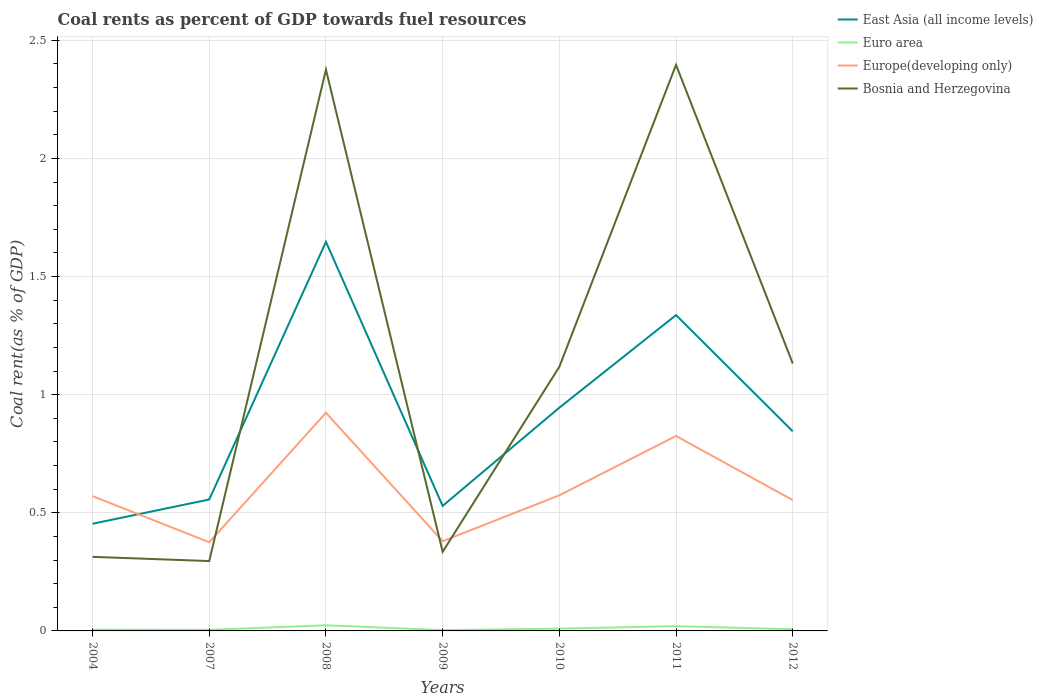Does the line corresponding to Bosnia and Herzegovina intersect with the line corresponding to Euro area?
Your answer should be very brief. No. Is the number of lines equal to the number of legend labels?
Keep it short and to the point. Yes. Across all years, what is the maximum coal rent in East Asia (all income levels)?
Offer a terse response. 0.45. What is the total coal rent in Europe(developing only) in the graph?
Your answer should be compact. -0.25. What is the difference between the highest and the second highest coal rent in Bosnia and Herzegovina?
Offer a terse response. 2.1. How many lines are there?
Offer a very short reply. 4. How many years are there in the graph?
Offer a terse response. 7. Does the graph contain any zero values?
Your response must be concise. No. How many legend labels are there?
Your response must be concise. 4. What is the title of the graph?
Your answer should be very brief. Coal rents as percent of GDP towards fuel resources. Does "Uganda" appear as one of the legend labels in the graph?
Keep it short and to the point. No. What is the label or title of the X-axis?
Make the answer very short. Years. What is the label or title of the Y-axis?
Provide a short and direct response. Coal rent(as % of GDP). What is the Coal rent(as % of GDP) in East Asia (all income levels) in 2004?
Offer a very short reply. 0.45. What is the Coal rent(as % of GDP) in Euro area in 2004?
Make the answer very short. 0.01. What is the Coal rent(as % of GDP) in Europe(developing only) in 2004?
Provide a succinct answer. 0.57. What is the Coal rent(as % of GDP) of Bosnia and Herzegovina in 2004?
Ensure brevity in your answer.  0.31. What is the Coal rent(as % of GDP) of East Asia (all income levels) in 2007?
Your answer should be compact. 0.56. What is the Coal rent(as % of GDP) in Euro area in 2007?
Make the answer very short. 0. What is the Coal rent(as % of GDP) in Europe(developing only) in 2007?
Offer a terse response. 0.38. What is the Coal rent(as % of GDP) of Bosnia and Herzegovina in 2007?
Give a very brief answer. 0.3. What is the Coal rent(as % of GDP) of East Asia (all income levels) in 2008?
Offer a terse response. 1.65. What is the Coal rent(as % of GDP) in Euro area in 2008?
Make the answer very short. 0.02. What is the Coal rent(as % of GDP) of Europe(developing only) in 2008?
Your answer should be compact. 0.92. What is the Coal rent(as % of GDP) in Bosnia and Herzegovina in 2008?
Offer a very short reply. 2.38. What is the Coal rent(as % of GDP) in East Asia (all income levels) in 2009?
Make the answer very short. 0.53. What is the Coal rent(as % of GDP) in Euro area in 2009?
Provide a short and direct response. 0. What is the Coal rent(as % of GDP) of Europe(developing only) in 2009?
Make the answer very short. 0.38. What is the Coal rent(as % of GDP) in Bosnia and Herzegovina in 2009?
Your answer should be very brief. 0.33. What is the Coal rent(as % of GDP) in East Asia (all income levels) in 2010?
Give a very brief answer. 0.95. What is the Coal rent(as % of GDP) of Euro area in 2010?
Ensure brevity in your answer.  0.01. What is the Coal rent(as % of GDP) in Europe(developing only) in 2010?
Your response must be concise. 0.57. What is the Coal rent(as % of GDP) of Bosnia and Herzegovina in 2010?
Make the answer very short. 1.12. What is the Coal rent(as % of GDP) of East Asia (all income levels) in 2011?
Provide a short and direct response. 1.34. What is the Coal rent(as % of GDP) of Euro area in 2011?
Offer a terse response. 0.02. What is the Coal rent(as % of GDP) of Europe(developing only) in 2011?
Give a very brief answer. 0.83. What is the Coal rent(as % of GDP) of Bosnia and Herzegovina in 2011?
Offer a terse response. 2.4. What is the Coal rent(as % of GDP) of East Asia (all income levels) in 2012?
Give a very brief answer. 0.84. What is the Coal rent(as % of GDP) of Euro area in 2012?
Your response must be concise. 0.01. What is the Coal rent(as % of GDP) of Europe(developing only) in 2012?
Your answer should be very brief. 0.55. What is the Coal rent(as % of GDP) of Bosnia and Herzegovina in 2012?
Give a very brief answer. 1.13. Across all years, what is the maximum Coal rent(as % of GDP) in East Asia (all income levels)?
Provide a short and direct response. 1.65. Across all years, what is the maximum Coal rent(as % of GDP) in Euro area?
Offer a very short reply. 0.02. Across all years, what is the maximum Coal rent(as % of GDP) of Europe(developing only)?
Make the answer very short. 0.92. Across all years, what is the maximum Coal rent(as % of GDP) of Bosnia and Herzegovina?
Your response must be concise. 2.4. Across all years, what is the minimum Coal rent(as % of GDP) in East Asia (all income levels)?
Offer a terse response. 0.45. Across all years, what is the minimum Coal rent(as % of GDP) of Euro area?
Ensure brevity in your answer.  0. Across all years, what is the minimum Coal rent(as % of GDP) in Europe(developing only)?
Offer a terse response. 0.38. Across all years, what is the minimum Coal rent(as % of GDP) in Bosnia and Herzegovina?
Offer a terse response. 0.3. What is the total Coal rent(as % of GDP) of East Asia (all income levels) in the graph?
Provide a succinct answer. 6.31. What is the total Coal rent(as % of GDP) of Euro area in the graph?
Offer a very short reply. 0.07. What is the total Coal rent(as % of GDP) in Europe(developing only) in the graph?
Keep it short and to the point. 4.2. What is the total Coal rent(as % of GDP) of Bosnia and Herzegovina in the graph?
Give a very brief answer. 7.97. What is the difference between the Coal rent(as % of GDP) of East Asia (all income levels) in 2004 and that in 2007?
Provide a succinct answer. -0.1. What is the difference between the Coal rent(as % of GDP) of Euro area in 2004 and that in 2007?
Provide a short and direct response. 0. What is the difference between the Coal rent(as % of GDP) in Europe(developing only) in 2004 and that in 2007?
Your answer should be very brief. 0.2. What is the difference between the Coal rent(as % of GDP) of Bosnia and Herzegovina in 2004 and that in 2007?
Give a very brief answer. 0.02. What is the difference between the Coal rent(as % of GDP) of East Asia (all income levels) in 2004 and that in 2008?
Make the answer very short. -1.19. What is the difference between the Coal rent(as % of GDP) in Euro area in 2004 and that in 2008?
Offer a terse response. -0.02. What is the difference between the Coal rent(as % of GDP) in Europe(developing only) in 2004 and that in 2008?
Make the answer very short. -0.35. What is the difference between the Coal rent(as % of GDP) in Bosnia and Herzegovina in 2004 and that in 2008?
Ensure brevity in your answer.  -2.06. What is the difference between the Coal rent(as % of GDP) of East Asia (all income levels) in 2004 and that in 2009?
Ensure brevity in your answer.  -0.08. What is the difference between the Coal rent(as % of GDP) in Euro area in 2004 and that in 2009?
Provide a succinct answer. 0. What is the difference between the Coal rent(as % of GDP) in Europe(developing only) in 2004 and that in 2009?
Your answer should be compact. 0.19. What is the difference between the Coal rent(as % of GDP) in Bosnia and Herzegovina in 2004 and that in 2009?
Keep it short and to the point. -0.02. What is the difference between the Coal rent(as % of GDP) in East Asia (all income levels) in 2004 and that in 2010?
Provide a succinct answer. -0.49. What is the difference between the Coal rent(as % of GDP) of Euro area in 2004 and that in 2010?
Make the answer very short. -0. What is the difference between the Coal rent(as % of GDP) in Europe(developing only) in 2004 and that in 2010?
Keep it short and to the point. -0. What is the difference between the Coal rent(as % of GDP) of Bosnia and Herzegovina in 2004 and that in 2010?
Your answer should be compact. -0.8. What is the difference between the Coal rent(as % of GDP) of East Asia (all income levels) in 2004 and that in 2011?
Ensure brevity in your answer.  -0.88. What is the difference between the Coal rent(as % of GDP) of Euro area in 2004 and that in 2011?
Provide a short and direct response. -0.01. What is the difference between the Coal rent(as % of GDP) in Europe(developing only) in 2004 and that in 2011?
Ensure brevity in your answer.  -0.25. What is the difference between the Coal rent(as % of GDP) of Bosnia and Herzegovina in 2004 and that in 2011?
Give a very brief answer. -2.08. What is the difference between the Coal rent(as % of GDP) of East Asia (all income levels) in 2004 and that in 2012?
Your response must be concise. -0.39. What is the difference between the Coal rent(as % of GDP) in Euro area in 2004 and that in 2012?
Provide a succinct answer. -0. What is the difference between the Coal rent(as % of GDP) in Europe(developing only) in 2004 and that in 2012?
Give a very brief answer. 0.02. What is the difference between the Coal rent(as % of GDP) in Bosnia and Herzegovina in 2004 and that in 2012?
Keep it short and to the point. -0.82. What is the difference between the Coal rent(as % of GDP) in East Asia (all income levels) in 2007 and that in 2008?
Keep it short and to the point. -1.09. What is the difference between the Coal rent(as % of GDP) in Euro area in 2007 and that in 2008?
Offer a terse response. -0.02. What is the difference between the Coal rent(as % of GDP) of Europe(developing only) in 2007 and that in 2008?
Make the answer very short. -0.55. What is the difference between the Coal rent(as % of GDP) in Bosnia and Herzegovina in 2007 and that in 2008?
Your answer should be compact. -2.08. What is the difference between the Coal rent(as % of GDP) of East Asia (all income levels) in 2007 and that in 2009?
Make the answer very short. 0.03. What is the difference between the Coal rent(as % of GDP) in Euro area in 2007 and that in 2009?
Your answer should be very brief. 0. What is the difference between the Coal rent(as % of GDP) in Europe(developing only) in 2007 and that in 2009?
Ensure brevity in your answer.  -0. What is the difference between the Coal rent(as % of GDP) in Bosnia and Herzegovina in 2007 and that in 2009?
Offer a terse response. -0.04. What is the difference between the Coal rent(as % of GDP) of East Asia (all income levels) in 2007 and that in 2010?
Offer a terse response. -0.39. What is the difference between the Coal rent(as % of GDP) in Euro area in 2007 and that in 2010?
Make the answer very short. -0.01. What is the difference between the Coal rent(as % of GDP) of Europe(developing only) in 2007 and that in 2010?
Your answer should be compact. -0.2. What is the difference between the Coal rent(as % of GDP) in Bosnia and Herzegovina in 2007 and that in 2010?
Your answer should be very brief. -0.82. What is the difference between the Coal rent(as % of GDP) of East Asia (all income levels) in 2007 and that in 2011?
Provide a short and direct response. -0.78. What is the difference between the Coal rent(as % of GDP) in Euro area in 2007 and that in 2011?
Your answer should be very brief. -0.02. What is the difference between the Coal rent(as % of GDP) of Europe(developing only) in 2007 and that in 2011?
Ensure brevity in your answer.  -0.45. What is the difference between the Coal rent(as % of GDP) of Bosnia and Herzegovina in 2007 and that in 2011?
Your answer should be compact. -2.1. What is the difference between the Coal rent(as % of GDP) in East Asia (all income levels) in 2007 and that in 2012?
Provide a short and direct response. -0.29. What is the difference between the Coal rent(as % of GDP) in Euro area in 2007 and that in 2012?
Your response must be concise. -0. What is the difference between the Coal rent(as % of GDP) in Europe(developing only) in 2007 and that in 2012?
Ensure brevity in your answer.  -0.18. What is the difference between the Coal rent(as % of GDP) of Bosnia and Herzegovina in 2007 and that in 2012?
Provide a short and direct response. -0.84. What is the difference between the Coal rent(as % of GDP) of East Asia (all income levels) in 2008 and that in 2009?
Your response must be concise. 1.12. What is the difference between the Coal rent(as % of GDP) of Euro area in 2008 and that in 2009?
Give a very brief answer. 0.02. What is the difference between the Coal rent(as % of GDP) of Europe(developing only) in 2008 and that in 2009?
Give a very brief answer. 0.54. What is the difference between the Coal rent(as % of GDP) of Bosnia and Herzegovina in 2008 and that in 2009?
Your answer should be very brief. 2.04. What is the difference between the Coal rent(as % of GDP) in East Asia (all income levels) in 2008 and that in 2010?
Offer a terse response. 0.7. What is the difference between the Coal rent(as % of GDP) in Euro area in 2008 and that in 2010?
Offer a very short reply. 0.01. What is the difference between the Coal rent(as % of GDP) in Europe(developing only) in 2008 and that in 2010?
Give a very brief answer. 0.35. What is the difference between the Coal rent(as % of GDP) in Bosnia and Herzegovina in 2008 and that in 2010?
Ensure brevity in your answer.  1.26. What is the difference between the Coal rent(as % of GDP) in East Asia (all income levels) in 2008 and that in 2011?
Keep it short and to the point. 0.31. What is the difference between the Coal rent(as % of GDP) in Euro area in 2008 and that in 2011?
Give a very brief answer. 0. What is the difference between the Coal rent(as % of GDP) of Europe(developing only) in 2008 and that in 2011?
Provide a succinct answer. 0.1. What is the difference between the Coal rent(as % of GDP) in Bosnia and Herzegovina in 2008 and that in 2011?
Your answer should be very brief. -0.02. What is the difference between the Coal rent(as % of GDP) of East Asia (all income levels) in 2008 and that in 2012?
Your answer should be compact. 0.8. What is the difference between the Coal rent(as % of GDP) of Euro area in 2008 and that in 2012?
Provide a succinct answer. 0.02. What is the difference between the Coal rent(as % of GDP) of Europe(developing only) in 2008 and that in 2012?
Offer a very short reply. 0.37. What is the difference between the Coal rent(as % of GDP) in Bosnia and Herzegovina in 2008 and that in 2012?
Ensure brevity in your answer.  1.24. What is the difference between the Coal rent(as % of GDP) in East Asia (all income levels) in 2009 and that in 2010?
Your answer should be compact. -0.42. What is the difference between the Coal rent(as % of GDP) of Euro area in 2009 and that in 2010?
Ensure brevity in your answer.  -0.01. What is the difference between the Coal rent(as % of GDP) in Europe(developing only) in 2009 and that in 2010?
Keep it short and to the point. -0.19. What is the difference between the Coal rent(as % of GDP) of Bosnia and Herzegovina in 2009 and that in 2010?
Keep it short and to the point. -0.78. What is the difference between the Coal rent(as % of GDP) in East Asia (all income levels) in 2009 and that in 2011?
Give a very brief answer. -0.81. What is the difference between the Coal rent(as % of GDP) in Euro area in 2009 and that in 2011?
Your response must be concise. -0.02. What is the difference between the Coal rent(as % of GDP) in Europe(developing only) in 2009 and that in 2011?
Keep it short and to the point. -0.45. What is the difference between the Coal rent(as % of GDP) of Bosnia and Herzegovina in 2009 and that in 2011?
Ensure brevity in your answer.  -2.06. What is the difference between the Coal rent(as % of GDP) in East Asia (all income levels) in 2009 and that in 2012?
Offer a very short reply. -0.32. What is the difference between the Coal rent(as % of GDP) of Euro area in 2009 and that in 2012?
Give a very brief answer. -0. What is the difference between the Coal rent(as % of GDP) in Europe(developing only) in 2009 and that in 2012?
Provide a succinct answer. -0.17. What is the difference between the Coal rent(as % of GDP) of Bosnia and Herzegovina in 2009 and that in 2012?
Provide a short and direct response. -0.8. What is the difference between the Coal rent(as % of GDP) in East Asia (all income levels) in 2010 and that in 2011?
Offer a very short reply. -0.39. What is the difference between the Coal rent(as % of GDP) of Euro area in 2010 and that in 2011?
Your answer should be very brief. -0.01. What is the difference between the Coal rent(as % of GDP) in Europe(developing only) in 2010 and that in 2011?
Your response must be concise. -0.25. What is the difference between the Coal rent(as % of GDP) of Bosnia and Herzegovina in 2010 and that in 2011?
Ensure brevity in your answer.  -1.28. What is the difference between the Coal rent(as % of GDP) in East Asia (all income levels) in 2010 and that in 2012?
Keep it short and to the point. 0.1. What is the difference between the Coal rent(as % of GDP) of Euro area in 2010 and that in 2012?
Ensure brevity in your answer.  0. What is the difference between the Coal rent(as % of GDP) in Europe(developing only) in 2010 and that in 2012?
Offer a terse response. 0.02. What is the difference between the Coal rent(as % of GDP) of Bosnia and Herzegovina in 2010 and that in 2012?
Give a very brief answer. -0.01. What is the difference between the Coal rent(as % of GDP) of East Asia (all income levels) in 2011 and that in 2012?
Ensure brevity in your answer.  0.49. What is the difference between the Coal rent(as % of GDP) of Euro area in 2011 and that in 2012?
Make the answer very short. 0.01. What is the difference between the Coal rent(as % of GDP) of Europe(developing only) in 2011 and that in 2012?
Offer a very short reply. 0.27. What is the difference between the Coal rent(as % of GDP) in Bosnia and Herzegovina in 2011 and that in 2012?
Offer a very short reply. 1.26. What is the difference between the Coal rent(as % of GDP) in East Asia (all income levels) in 2004 and the Coal rent(as % of GDP) in Euro area in 2007?
Offer a terse response. 0.45. What is the difference between the Coal rent(as % of GDP) in East Asia (all income levels) in 2004 and the Coal rent(as % of GDP) in Europe(developing only) in 2007?
Your answer should be compact. 0.08. What is the difference between the Coal rent(as % of GDP) in East Asia (all income levels) in 2004 and the Coal rent(as % of GDP) in Bosnia and Herzegovina in 2007?
Your answer should be very brief. 0.16. What is the difference between the Coal rent(as % of GDP) of Euro area in 2004 and the Coal rent(as % of GDP) of Europe(developing only) in 2007?
Keep it short and to the point. -0.37. What is the difference between the Coal rent(as % of GDP) of Euro area in 2004 and the Coal rent(as % of GDP) of Bosnia and Herzegovina in 2007?
Your answer should be very brief. -0.29. What is the difference between the Coal rent(as % of GDP) of Europe(developing only) in 2004 and the Coal rent(as % of GDP) of Bosnia and Herzegovina in 2007?
Give a very brief answer. 0.27. What is the difference between the Coal rent(as % of GDP) of East Asia (all income levels) in 2004 and the Coal rent(as % of GDP) of Euro area in 2008?
Ensure brevity in your answer.  0.43. What is the difference between the Coal rent(as % of GDP) in East Asia (all income levels) in 2004 and the Coal rent(as % of GDP) in Europe(developing only) in 2008?
Offer a very short reply. -0.47. What is the difference between the Coal rent(as % of GDP) in East Asia (all income levels) in 2004 and the Coal rent(as % of GDP) in Bosnia and Herzegovina in 2008?
Offer a terse response. -1.92. What is the difference between the Coal rent(as % of GDP) of Euro area in 2004 and the Coal rent(as % of GDP) of Europe(developing only) in 2008?
Ensure brevity in your answer.  -0.92. What is the difference between the Coal rent(as % of GDP) of Euro area in 2004 and the Coal rent(as % of GDP) of Bosnia and Herzegovina in 2008?
Your response must be concise. -2.37. What is the difference between the Coal rent(as % of GDP) in Europe(developing only) in 2004 and the Coal rent(as % of GDP) in Bosnia and Herzegovina in 2008?
Provide a succinct answer. -1.81. What is the difference between the Coal rent(as % of GDP) in East Asia (all income levels) in 2004 and the Coal rent(as % of GDP) in Euro area in 2009?
Give a very brief answer. 0.45. What is the difference between the Coal rent(as % of GDP) in East Asia (all income levels) in 2004 and the Coal rent(as % of GDP) in Europe(developing only) in 2009?
Ensure brevity in your answer.  0.07. What is the difference between the Coal rent(as % of GDP) in East Asia (all income levels) in 2004 and the Coal rent(as % of GDP) in Bosnia and Herzegovina in 2009?
Your answer should be very brief. 0.12. What is the difference between the Coal rent(as % of GDP) in Euro area in 2004 and the Coal rent(as % of GDP) in Europe(developing only) in 2009?
Your answer should be compact. -0.37. What is the difference between the Coal rent(as % of GDP) in Euro area in 2004 and the Coal rent(as % of GDP) in Bosnia and Herzegovina in 2009?
Keep it short and to the point. -0.33. What is the difference between the Coal rent(as % of GDP) in Europe(developing only) in 2004 and the Coal rent(as % of GDP) in Bosnia and Herzegovina in 2009?
Your answer should be compact. 0.24. What is the difference between the Coal rent(as % of GDP) in East Asia (all income levels) in 2004 and the Coal rent(as % of GDP) in Euro area in 2010?
Your answer should be very brief. 0.44. What is the difference between the Coal rent(as % of GDP) of East Asia (all income levels) in 2004 and the Coal rent(as % of GDP) of Europe(developing only) in 2010?
Your answer should be very brief. -0.12. What is the difference between the Coal rent(as % of GDP) of East Asia (all income levels) in 2004 and the Coal rent(as % of GDP) of Bosnia and Herzegovina in 2010?
Provide a short and direct response. -0.66. What is the difference between the Coal rent(as % of GDP) of Euro area in 2004 and the Coal rent(as % of GDP) of Europe(developing only) in 2010?
Your response must be concise. -0.57. What is the difference between the Coal rent(as % of GDP) of Euro area in 2004 and the Coal rent(as % of GDP) of Bosnia and Herzegovina in 2010?
Give a very brief answer. -1.11. What is the difference between the Coal rent(as % of GDP) in Europe(developing only) in 2004 and the Coal rent(as % of GDP) in Bosnia and Herzegovina in 2010?
Your response must be concise. -0.55. What is the difference between the Coal rent(as % of GDP) of East Asia (all income levels) in 2004 and the Coal rent(as % of GDP) of Euro area in 2011?
Provide a short and direct response. 0.43. What is the difference between the Coal rent(as % of GDP) in East Asia (all income levels) in 2004 and the Coal rent(as % of GDP) in Europe(developing only) in 2011?
Your response must be concise. -0.37. What is the difference between the Coal rent(as % of GDP) in East Asia (all income levels) in 2004 and the Coal rent(as % of GDP) in Bosnia and Herzegovina in 2011?
Offer a terse response. -1.94. What is the difference between the Coal rent(as % of GDP) in Euro area in 2004 and the Coal rent(as % of GDP) in Europe(developing only) in 2011?
Offer a terse response. -0.82. What is the difference between the Coal rent(as % of GDP) of Euro area in 2004 and the Coal rent(as % of GDP) of Bosnia and Herzegovina in 2011?
Keep it short and to the point. -2.39. What is the difference between the Coal rent(as % of GDP) in Europe(developing only) in 2004 and the Coal rent(as % of GDP) in Bosnia and Herzegovina in 2011?
Your answer should be very brief. -1.83. What is the difference between the Coal rent(as % of GDP) of East Asia (all income levels) in 2004 and the Coal rent(as % of GDP) of Euro area in 2012?
Ensure brevity in your answer.  0.45. What is the difference between the Coal rent(as % of GDP) in East Asia (all income levels) in 2004 and the Coal rent(as % of GDP) in Europe(developing only) in 2012?
Your answer should be very brief. -0.1. What is the difference between the Coal rent(as % of GDP) of East Asia (all income levels) in 2004 and the Coal rent(as % of GDP) of Bosnia and Herzegovina in 2012?
Give a very brief answer. -0.68. What is the difference between the Coal rent(as % of GDP) of Euro area in 2004 and the Coal rent(as % of GDP) of Europe(developing only) in 2012?
Make the answer very short. -0.55. What is the difference between the Coal rent(as % of GDP) of Euro area in 2004 and the Coal rent(as % of GDP) of Bosnia and Herzegovina in 2012?
Offer a terse response. -1.13. What is the difference between the Coal rent(as % of GDP) of Europe(developing only) in 2004 and the Coal rent(as % of GDP) of Bosnia and Herzegovina in 2012?
Make the answer very short. -0.56. What is the difference between the Coal rent(as % of GDP) in East Asia (all income levels) in 2007 and the Coal rent(as % of GDP) in Euro area in 2008?
Keep it short and to the point. 0.53. What is the difference between the Coal rent(as % of GDP) of East Asia (all income levels) in 2007 and the Coal rent(as % of GDP) of Europe(developing only) in 2008?
Provide a short and direct response. -0.37. What is the difference between the Coal rent(as % of GDP) in East Asia (all income levels) in 2007 and the Coal rent(as % of GDP) in Bosnia and Herzegovina in 2008?
Offer a very short reply. -1.82. What is the difference between the Coal rent(as % of GDP) of Euro area in 2007 and the Coal rent(as % of GDP) of Europe(developing only) in 2008?
Offer a very short reply. -0.92. What is the difference between the Coal rent(as % of GDP) of Euro area in 2007 and the Coal rent(as % of GDP) of Bosnia and Herzegovina in 2008?
Offer a very short reply. -2.37. What is the difference between the Coal rent(as % of GDP) of Europe(developing only) in 2007 and the Coal rent(as % of GDP) of Bosnia and Herzegovina in 2008?
Provide a succinct answer. -2. What is the difference between the Coal rent(as % of GDP) in East Asia (all income levels) in 2007 and the Coal rent(as % of GDP) in Euro area in 2009?
Your answer should be compact. 0.55. What is the difference between the Coal rent(as % of GDP) in East Asia (all income levels) in 2007 and the Coal rent(as % of GDP) in Europe(developing only) in 2009?
Offer a terse response. 0.18. What is the difference between the Coal rent(as % of GDP) in East Asia (all income levels) in 2007 and the Coal rent(as % of GDP) in Bosnia and Herzegovina in 2009?
Provide a succinct answer. 0.22. What is the difference between the Coal rent(as % of GDP) in Euro area in 2007 and the Coal rent(as % of GDP) in Europe(developing only) in 2009?
Make the answer very short. -0.38. What is the difference between the Coal rent(as % of GDP) in Euro area in 2007 and the Coal rent(as % of GDP) in Bosnia and Herzegovina in 2009?
Make the answer very short. -0.33. What is the difference between the Coal rent(as % of GDP) in Europe(developing only) in 2007 and the Coal rent(as % of GDP) in Bosnia and Herzegovina in 2009?
Keep it short and to the point. 0.04. What is the difference between the Coal rent(as % of GDP) in East Asia (all income levels) in 2007 and the Coal rent(as % of GDP) in Euro area in 2010?
Give a very brief answer. 0.55. What is the difference between the Coal rent(as % of GDP) of East Asia (all income levels) in 2007 and the Coal rent(as % of GDP) of Europe(developing only) in 2010?
Provide a short and direct response. -0.02. What is the difference between the Coal rent(as % of GDP) in East Asia (all income levels) in 2007 and the Coal rent(as % of GDP) in Bosnia and Herzegovina in 2010?
Ensure brevity in your answer.  -0.56. What is the difference between the Coal rent(as % of GDP) of Euro area in 2007 and the Coal rent(as % of GDP) of Europe(developing only) in 2010?
Provide a short and direct response. -0.57. What is the difference between the Coal rent(as % of GDP) in Euro area in 2007 and the Coal rent(as % of GDP) in Bosnia and Herzegovina in 2010?
Your response must be concise. -1.11. What is the difference between the Coal rent(as % of GDP) of Europe(developing only) in 2007 and the Coal rent(as % of GDP) of Bosnia and Herzegovina in 2010?
Your answer should be compact. -0.74. What is the difference between the Coal rent(as % of GDP) in East Asia (all income levels) in 2007 and the Coal rent(as % of GDP) in Euro area in 2011?
Your answer should be compact. 0.54. What is the difference between the Coal rent(as % of GDP) in East Asia (all income levels) in 2007 and the Coal rent(as % of GDP) in Europe(developing only) in 2011?
Offer a terse response. -0.27. What is the difference between the Coal rent(as % of GDP) of East Asia (all income levels) in 2007 and the Coal rent(as % of GDP) of Bosnia and Herzegovina in 2011?
Your answer should be very brief. -1.84. What is the difference between the Coal rent(as % of GDP) of Euro area in 2007 and the Coal rent(as % of GDP) of Europe(developing only) in 2011?
Your answer should be very brief. -0.82. What is the difference between the Coal rent(as % of GDP) of Euro area in 2007 and the Coal rent(as % of GDP) of Bosnia and Herzegovina in 2011?
Ensure brevity in your answer.  -2.39. What is the difference between the Coal rent(as % of GDP) of Europe(developing only) in 2007 and the Coal rent(as % of GDP) of Bosnia and Herzegovina in 2011?
Make the answer very short. -2.02. What is the difference between the Coal rent(as % of GDP) in East Asia (all income levels) in 2007 and the Coal rent(as % of GDP) in Euro area in 2012?
Your response must be concise. 0.55. What is the difference between the Coal rent(as % of GDP) in East Asia (all income levels) in 2007 and the Coal rent(as % of GDP) in Europe(developing only) in 2012?
Your response must be concise. 0. What is the difference between the Coal rent(as % of GDP) in East Asia (all income levels) in 2007 and the Coal rent(as % of GDP) in Bosnia and Herzegovina in 2012?
Give a very brief answer. -0.58. What is the difference between the Coal rent(as % of GDP) of Euro area in 2007 and the Coal rent(as % of GDP) of Europe(developing only) in 2012?
Offer a very short reply. -0.55. What is the difference between the Coal rent(as % of GDP) of Euro area in 2007 and the Coal rent(as % of GDP) of Bosnia and Herzegovina in 2012?
Offer a terse response. -1.13. What is the difference between the Coal rent(as % of GDP) of Europe(developing only) in 2007 and the Coal rent(as % of GDP) of Bosnia and Herzegovina in 2012?
Make the answer very short. -0.76. What is the difference between the Coal rent(as % of GDP) of East Asia (all income levels) in 2008 and the Coal rent(as % of GDP) of Euro area in 2009?
Provide a succinct answer. 1.64. What is the difference between the Coal rent(as % of GDP) of East Asia (all income levels) in 2008 and the Coal rent(as % of GDP) of Europe(developing only) in 2009?
Offer a terse response. 1.27. What is the difference between the Coal rent(as % of GDP) of East Asia (all income levels) in 2008 and the Coal rent(as % of GDP) of Bosnia and Herzegovina in 2009?
Your answer should be compact. 1.31. What is the difference between the Coal rent(as % of GDP) in Euro area in 2008 and the Coal rent(as % of GDP) in Europe(developing only) in 2009?
Your answer should be compact. -0.36. What is the difference between the Coal rent(as % of GDP) in Euro area in 2008 and the Coal rent(as % of GDP) in Bosnia and Herzegovina in 2009?
Your answer should be compact. -0.31. What is the difference between the Coal rent(as % of GDP) in Europe(developing only) in 2008 and the Coal rent(as % of GDP) in Bosnia and Herzegovina in 2009?
Your answer should be compact. 0.59. What is the difference between the Coal rent(as % of GDP) of East Asia (all income levels) in 2008 and the Coal rent(as % of GDP) of Euro area in 2010?
Your answer should be compact. 1.64. What is the difference between the Coal rent(as % of GDP) of East Asia (all income levels) in 2008 and the Coal rent(as % of GDP) of Europe(developing only) in 2010?
Your response must be concise. 1.07. What is the difference between the Coal rent(as % of GDP) of East Asia (all income levels) in 2008 and the Coal rent(as % of GDP) of Bosnia and Herzegovina in 2010?
Provide a succinct answer. 0.53. What is the difference between the Coal rent(as % of GDP) in Euro area in 2008 and the Coal rent(as % of GDP) in Europe(developing only) in 2010?
Your answer should be compact. -0.55. What is the difference between the Coal rent(as % of GDP) in Euro area in 2008 and the Coal rent(as % of GDP) in Bosnia and Herzegovina in 2010?
Your answer should be very brief. -1.09. What is the difference between the Coal rent(as % of GDP) of Europe(developing only) in 2008 and the Coal rent(as % of GDP) of Bosnia and Herzegovina in 2010?
Your answer should be compact. -0.19. What is the difference between the Coal rent(as % of GDP) in East Asia (all income levels) in 2008 and the Coal rent(as % of GDP) in Euro area in 2011?
Your response must be concise. 1.63. What is the difference between the Coal rent(as % of GDP) of East Asia (all income levels) in 2008 and the Coal rent(as % of GDP) of Europe(developing only) in 2011?
Ensure brevity in your answer.  0.82. What is the difference between the Coal rent(as % of GDP) in East Asia (all income levels) in 2008 and the Coal rent(as % of GDP) in Bosnia and Herzegovina in 2011?
Provide a succinct answer. -0.75. What is the difference between the Coal rent(as % of GDP) of Euro area in 2008 and the Coal rent(as % of GDP) of Europe(developing only) in 2011?
Your answer should be compact. -0.8. What is the difference between the Coal rent(as % of GDP) in Euro area in 2008 and the Coal rent(as % of GDP) in Bosnia and Herzegovina in 2011?
Give a very brief answer. -2.37. What is the difference between the Coal rent(as % of GDP) of Europe(developing only) in 2008 and the Coal rent(as % of GDP) of Bosnia and Herzegovina in 2011?
Offer a terse response. -1.47. What is the difference between the Coal rent(as % of GDP) of East Asia (all income levels) in 2008 and the Coal rent(as % of GDP) of Euro area in 2012?
Offer a very short reply. 1.64. What is the difference between the Coal rent(as % of GDP) in East Asia (all income levels) in 2008 and the Coal rent(as % of GDP) in Europe(developing only) in 2012?
Offer a terse response. 1.09. What is the difference between the Coal rent(as % of GDP) in East Asia (all income levels) in 2008 and the Coal rent(as % of GDP) in Bosnia and Herzegovina in 2012?
Make the answer very short. 0.52. What is the difference between the Coal rent(as % of GDP) in Euro area in 2008 and the Coal rent(as % of GDP) in Europe(developing only) in 2012?
Ensure brevity in your answer.  -0.53. What is the difference between the Coal rent(as % of GDP) in Euro area in 2008 and the Coal rent(as % of GDP) in Bosnia and Herzegovina in 2012?
Your response must be concise. -1.11. What is the difference between the Coal rent(as % of GDP) in Europe(developing only) in 2008 and the Coal rent(as % of GDP) in Bosnia and Herzegovina in 2012?
Ensure brevity in your answer.  -0.21. What is the difference between the Coal rent(as % of GDP) of East Asia (all income levels) in 2009 and the Coal rent(as % of GDP) of Euro area in 2010?
Keep it short and to the point. 0.52. What is the difference between the Coal rent(as % of GDP) of East Asia (all income levels) in 2009 and the Coal rent(as % of GDP) of Europe(developing only) in 2010?
Your answer should be compact. -0.04. What is the difference between the Coal rent(as % of GDP) of East Asia (all income levels) in 2009 and the Coal rent(as % of GDP) of Bosnia and Herzegovina in 2010?
Offer a terse response. -0.59. What is the difference between the Coal rent(as % of GDP) in Euro area in 2009 and the Coal rent(as % of GDP) in Europe(developing only) in 2010?
Ensure brevity in your answer.  -0.57. What is the difference between the Coal rent(as % of GDP) in Euro area in 2009 and the Coal rent(as % of GDP) in Bosnia and Herzegovina in 2010?
Keep it short and to the point. -1.11. What is the difference between the Coal rent(as % of GDP) in Europe(developing only) in 2009 and the Coal rent(as % of GDP) in Bosnia and Herzegovina in 2010?
Your answer should be compact. -0.74. What is the difference between the Coal rent(as % of GDP) in East Asia (all income levels) in 2009 and the Coal rent(as % of GDP) in Euro area in 2011?
Your answer should be very brief. 0.51. What is the difference between the Coal rent(as % of GDP) of East Asia (all income levels) in 2009 and the Coal rent(as % of GDP) of Europe(developing only) in 2011?
Provide a short and direct response. -0.3. What is the difference between the Coal rent(as % of GDP) of East Asia (all income levels) in 2009 and the Coal rent(as % of GDP) of Bosnia and Herzegovina in 2011?
Your response must be concise. -1.87. What is the difference between the Coal rent(as % of GDP) of Euro area in 2009 and the Coal rent(as % of GDP) of Europe(developing only) in 2011?
Provide a short and direct response. -0.82. What is the difference between the Coal rent(as % of GDP) of Euro area in 2009 and the Coal rent(as % of GDP) of Bosnia and Herzegovina in 2011?
Keep it short and to the point. -2.39. What is the difference between the Coal rent(as % of GDP) of Europe(developing only) in 2009 and the Coal rent(as % of GDP) of Bosnia and Herzegovina in 2011?
Provide a short and direct response. -2.02. What is the difference between the Coal rent(as % of GDP) in East Asia (all income levels) in 2009 and the Coal rent(as % of GDP) in Euro area in 2012?
Provide a succinct answer. 0.52. What is the difference between the Coal rent(as % of GDP) of East Asia (all income levels) in 2009 and the Coal rent(as % of GDP) of Europe(developing only) in 2012?
Offer a terse response. -0.02. What is the difference between the Coal rent(as % of GDP) of East Asia (all income levels) in 2009 and the Coal rent(as % of GDP) of Bosnia and Herzegovina in 2012?
Ensure brevity in your answer.  -0.6. What is the difference between the Coal rent(as % of GDP) of Euro area in 2009 and the Coal rent(as % of GDP) of Europe(developing only) in 2012?
Your answer should be compact. -0.55. What is the difference between the Coal rent(as % of GDP) in Euro area in 2009 and the Coal rent(as % of GDP) in Bosnia and Herzegovina in 2012?
Your response must be concise. -1.13. What is the difference between the Coal rent(as % of GDP) of Europe(developing only) in 2009 and the Coal rent(as % of GDP) of Bosnia and Herzegovina in 2012?
Offer a very short reply. -0.75. What is the difference between the Coal rent(as % of GDP) in East Asia (all income levels) in 2010 and the Coal rent(as % of GDP) in Euro area in 2011?
Ensure brevity in your answer.  0.93. What is the difference between the Coal rent(as % of GDP) of East Asia (all income levels) in 2010 and the Coal rent(as % of GDP) of Europe(developing only) in 2011?
Provide a short and direct response. 0.12. What is the difference between the Coal rent(as % of GDP) in East Asia (all income levels) in 2010 and the Coal rent(as % of GDP) in Bosnia and Herzegovina in 2011?
Keep it short and to the point. -1.45. What is the difference between the Coal rent(as % of GDP) in Euro area in 2010 and the Coal rent(as % of GDP) in Europe(developing only) in 2011?
Make the answer very short. -0.82. What is the difference between the Coal rent(as % of GDP) in Euro area in 2010 and the Coal rent(as % of GDP) in Bosnia and Herzegovina in 2011?
Offer a very short reply. -2.39. What is the difference between the Coal rent(as % of GDP) in Europe(developing only) in 2010 and the Coal rent(as % of GDP) in Bosnia and Herzegovina in 2011?
Offer a very short reply. -1.82. What is the difference between the Coal rent(as % of GDP) of East Asia (all income levels) in 2010 and the Coal rent(as % of GDP) of Euro area in 2012?
Your answer should be very brief. 0.94. What is the difference between the Coal rent(as % of GDP) of East Asia (all income levels) in 2010 and the Coal rent(as % of GDP) of Europe(developing only) in 2012?
Make the answer very short. 0.39. What is the difference between the Coal rent(as % of GDP) of East Asia (all income levels) in 2010 and the Coal rent(as % of GDP) of Bosnia and Herzegovina in 2012?
Your answer should be compact. -0.19. What is the difference between the Coal rent(as % of GDP) in Euro area in 2010 and the Coal rent(as % of GDP) in Europe(developing only) in 2012?
Offer a terse response. -0.54. What is the difference between the Coal rent(as % of GDP) of Euro area in 2010 and the Coal rent(as % of GDP) of Bosnia and Herzegovina in 2012?
Provide a short and direct response. -1.12. What is the difference between the Coal rent(as % of GDP) of Europe(developing only) in 2010 and the Coal rent(as % of GDP) of Bosnia and Herzegovina in 2012?
Offer a terse response. -0.56. What is the difference between the Coal rent(as % of GDP) in East Asia (all income levels) in 2011 and the Coal rent(as % of GDP) in Euro area in 2012?
Keep it short and to the point. 1.33. What is the difference between the Coal rent(as % of GDP) in East Asia (all income levels) in 2011 and the Coal rent(as % of GDP) in Europe(developing only) in 2012?
Your answer should be compact. 0.78. What is the difference between the Coal rent(as % of GDP) of East Asia (all income levels) in 2011 and the Coal rent(as % of GDP) of Bosnia and Herzegovina in 2012?
Your response must be concise. 0.2. What is the difference between the Coal rent(as % of GDP) of Euro area in 2011 and the Coal rent(as % of GDP) of Europe(developing only) in 2012?
Ensure brevity in your answer.  -0.53. What is the difference between the Coal rent(as % of GDP) of Euro area in 2011 and the Coal rent(as % of GDP) of Bosnia and Herzegovina in 2012?
Your response must be concise. -1.11. What is the difference between the Coal rent(as % of GDP) of Europe(developing only) in 2011 and the Coal rent(as % of GDP) of Bosnia and Herzegovina in 2012?
Provide a succinct answer. -0.31. What is the average Coal rent(as % of GDP) in East Asia (all income levels) per year?
Keep it short and to the point. 0.9. What is the average Coal rent(as % of GDP) of Euro area per year?
Give a very brief answer. 0.01. What is the average Coal rent(as % of GDP) in Europe(developing only) per year?
Your answer should be very brief. 0.6. What is the average Coal rent(as % of GDP) in Bosnia and Herzegovina per year?
Offer a terse response. 1.14. In the year 2004, what is the difference between the Coal rent(as % of GDP) of East Asia (all income levels) and Coal rent(as % of GDP) of Euro area?
Make the answer very short. 0.45. In the year 2004, what is the difference between the Coal rent(as % of GDP) of East Asia (all income levels) and Coal rent(as % of GDP) of Europe(developing only)?
Offer a terse response. -0.12. In the year 2004, what is the difference between the Coal rent(as % of GDP) of East Asia (all income levels) and Coal rent(as % of GDP) of Bosnia and Herzegovina?
Keep it short and to the point. 0.14. In the year 2004, what is the difference between the Coal rent(as % of GDP) of Euro area and Coal rent(as % of GDP) of Europe(developing only)?
Your answer should be very brief. -0.57. In the year 2004, what is the difference between the Coal rent(as % of GDP) of Euro area and Coal rent(as % of GDP) of Bosnia and Herzegovina?
Offer a terse response. -0.31. In the year 2004, what is the difference between the Coal rent(as % of GDP) in Europe(developing only) and Coal rent(as % of GDP) in Bosnia and Herzegovina?
Your answer should be very brief. 0.26. In the year 2007, what is the difference between the Coal rent(as % of GDP) of East Asia (all income levels) and Coal rent(as % of GDP) of Euro area?
Offer a terse response. 0.55. In the year 2007, what is the difference between the Coal rent(as % of GDP) in East Asia (all income levels) and Coal rent(as % of GDP) in Europe(developing only)?
Give a very brief answer. 0.18. In the year 2007, what is the difference between the Coal rent(as % of GDP) of East Asia (all income levels) and Coal rent(as % of GDP) of Bosnia and Herzegovina?
Give a very brief answer. 0.26. In the year 2007, what is the difference between the Coal rent(as % of GDP) of Euro area and Coal rent(as % of GDP) of Europe(developing only)?
Your response must be concise. -0.37. In the year 2007, what is the difference between the Coal rent(as % of GDP) of Euro area and Coal rent(as % of GDP) of Bosnia and Herzegovina?
Offer a terse response. -0.29. In the year 2007, what is the difference between the Coal rent(as % of GDP) of Europe(developing only) and Coal rent(as % of GDP) of Bosnia and Herzegovina?
Ensure brevity in your answer.  0.08. In the year 2008, what is the difference between the Coal rent(as % of GDP) of East Asia (all income levels) and Coal rent(as % of GDP) of Euro area?
Give a very brief answer. 1.62. In the year 2008, what is the difference between the Coal rent(as % of GDP) in East Asia (all income levels) and Coal rent(as % of GDP) in Europe(developing only)?
Provide a short and direct response. 0.72. In the year 2008, what is the difference between the Coal rent(as % of GDP) of East Asia (all income levels) and Coal rent(as % of GDP) of Bosnia and Herzegovina?
Offer a terse response. -0.73. In the year 2008, what is the difference between the Coal rent(as % of GDP) of Euro area and Coal rent(as % of GDP) of Europe(developing only)?
Keep it short and to the point. -0.9. In the year 2008, what is the difference between the Coal rent(as % of GDP) in Euro area and Coal rent(as % of GDP) in Bosnia and Herzegovina?
Your answer should be very brief. -2.35. In the year 2008, what is the difference between the Coal rent(as % of GDP) in Europe(developing only) and Coal rent(as % of GDP) in Bosnia and Herzegovina?
Your answer should be compact. -1.45. In the year 2009, what is the difference between the Coal rent(as % of GDP) in East Asia (all income levels) and Coal rent(as % of GDP) in Euro area?
Ensure brevity in your answer.  0.53. In the year 2009, what is the difference between the Coal rent(as % of GDP) of East Asia (all income levels) and Coal rent(as % of GDP) of Europe(developing only)?
Your answer should be compact. 0.15. In the year 2009, what is the difference between the Coal rent(as % of GDP) of East Asia (all income levels) and Coal rent(as % of GDP) of Bosnia and Herzegovina?
Your answer should be very brief. 0.19. In the year 2009, what is the difference between the Coal rent(as % of GDP) in Euro area and Coal rent(as % of GDP) in Europe(developing only)?
Keep it short and to the point. -0.38. In the year 2009, what is the difference between the Coal rent(as % of GDP) in Euro area and Coal rent(as % of GDP) in Bosnia and Herzegovina?
Your answer should be compact. -0.33. In the year 2009, what is the difference between the Coal rent(as % of GDP) in Europe(developing only) and Coal rent(as % of GDP) in Bosnia and Herzegovina?
Offer a very short reply. 0.04. In the year 2010, what is the difference between the Coal rent(as % of GDP) of East Asia (all income levels) and Coal rent(as % of GDP) of Euro area?
Your response must be concise. 0.94. In the year 2010, what is the difference between the Coal rent(as % of GDP) of East Asia (all income levels) and Coal rent(as % of GDP) of Europe(developing only)?
Make the answer very short. 0.37. In the year 2010, what is the difference between the Coal rent(as % of GDP) in East Asia (all income levels) and Coal rent(as % of GDP) in Bosnia and Herzegovina?
Offer a terse response. -0.17. In the year 2010, what is the difference between the Coal rent(as % of GDP) in Euro area and Coal rent(as % of GDP) in Europe(developing only)?
Give a very brief answer. -0.56. In the year 2010, what is the difference between the Coal rent(as % of GDP) of Euro area and Coal rent(as % of GDP) of Bosnia and Herzegovina?
Make the answer very short. -1.11. In the year 2010, what is the difference between the Coal rent(as % of GDP) in Europe(developing only) and Coal rent(as % of GDP) in Bosnia and Herzegovina?
Ensure brevity in your answer.  -0.54. In the year 2011, what is the difference between the Coal rent(as % of GDP) in East Asia (all income levels) and Coal rent(as % of GDP) in Euro area?
Provide a succinct answer. 1.32. In the year 2011, what is the difference between the Coal rent(as % of GDP) in East Asia (all income levels) and Coal rent(as % of GDP) in Europe(developing only)?
Provide a short and direct response. 0.51. In the year 2011, what is the difference between the Coal rent(as % of GDP) in East Asia (all income levels) and Coal rent(as % of GDP) in Bosnia and Herzegovina?
Your answer should be very brief. -1.06. In the year 2011, what is the difference between the Coal rent(as % of GDP) in Euro area and Coal rent(as % of GDP) in Europe(developing only)?
Provide a short and direct response. -0.81. In the year 2011, what is the difference between the Coal rent(as % of GDP) in Euro area and Coal rent(as % of GDP) in Bosnia and Herzegovina?
Make the answer very short. -2.38. In the year 2011, what is the difference between the Coal rent(as % of GDP) in Europe(developing only) and Coal rent(as % of GDP) in Bosnia and Herzegovina?
Offer a terse response. -1.57. In the year 2012, what is the difference between the Coal rent(as % of GDP) of East Asia (all income levels) and Coal rent(as % of GDP) of Euro area?
Provide a short and direct response. 0.84. In the year 2012, what is the difference between the Coal rent(as % of GDP) in East Asia (all income levels) and Coal rent(as % of GDP) in Europe(developing only)?
Offer a very short reply. 0.29. In the year 2012, what is the difference between the Coal rent(as % of GDP) of East Asia (all income levels) and Coal rent(as % of GDP) of Bosnia and Herzegovina?
Your response must be concise. -0.29. In the year 2012, what is the difference between the Coal rent(as % of GDP) in Euro area and Coal rent(as % of GDP) in Europe(developing only)?
Keep it short and to the point. -0.55. In the year 2012, what is the difference between the Coal rent(as % of GDP) of Euro area and Coal rent(as % of GDP) of Bosnia and Herzegovina?
Give a very brief answer. -1.13. In the year 2012, what is the difference between the Coal rent(as % of GDP) in Europe(developing only) and Coal rent(as % of GDP) in Bosnia and Herzegovina?
Ensure brevity in your answer.  -0.58. What is the ratio of the Coal rent(as % of GDP) in East Asia (all income levels) in 2004 to that in 2007?
Give a very brief answer. 0.82. What is the ratio of the Coal rent(as % of GDP) in Euro area in 2004 to that in 2007?
Keep it short and to the point. 1.16. What is the ratio of the Coal rent(as % of GDP) in Europe(developing only) in 2004 to that in 2007?
Provide a succinct answer. 1.52. What is the ratio of the Coal rent(as % of GDP) of Bosnia and Herzegovina in 2004 to that in 2007?
Your response must be concise. 1.06. What is the ratio of the Coal rent(as % of GDP) in East Asia (all income levels) in 2004 to that in 2008?
Provide a short and direct response. 0.28. What is the ratio of the Coal rent(as % of GDP) in Euro area in 2004 to that in 2008?
Offer a terse response. 0.23. What is the ratio of the Coal rent(as % of GDP) of Europe(developing only) in 2004 to that in 2008?
Give a very brief answer. 0.62. What is the ratio of the Coal rent(as % of GDP) of Bosnia and Herzegovina in 2004 to that in 2008?
Your response must be concise. 0.13. What is the ratio of the Coal rent(as % of GDP) in Euro area in 2004 to that in 2009?
Provide a short and direct response. 1.59. What is the ratio of the Coal rent(as % of GDP) in Europe(developing only) in 2004 to that in 2009?
Your answer should be compact. 1.5. What is the ratio of the Coal rent(as % of GDP) in Bosnia and Herzegovina in 2004 to that in 2009?
Make the answer very short. 0.94. What is the ratio of the Coal rent(as % of GDP) in East Asia (all income levels) in 2004 to that in 2010?
Keep it short and to the point. 0.48. What is the ratio of the Coal rent(as % of GDP) in Euro area in 2004 to that in 2010?
Ensure brevity in your answer.  0.56. What is the ratio of the Coal rent(as % of GDP) of Bosnia and Herzegovina in 2004 to that in 2010?
Provide a succinct answer. 0.28. What is the ratio of the Coal rent(as % of GDP) of East Asia (all income levels) in 2004 to that in 2011?
Your answer should be compact. 0.34. What is the ratio of the Coal rent(as % of GDP) in Euro area in 2004 to that in 2011?
Make the answer very short. 0.27. What is the ratio of the Coal rent(as % of GDP) in Europe(developing only) in 2004 to that in 2011?
Give a very brief answer. 0.69. What is the ratio of the Coal rent(as % of GDP) of Bosnia and Herzegovina in 2004 to that in 2011?
Keep it short and to the point. 0.13. What is the ratio of the Coal rent(as % of GDP) in East Asia (all income levels) in 2004 to that in 2012?
Provide a short and direct response. 0.54. What is the ratio of the Coal rent(as % of GDP) in Euro area in 2004 to that in 2012?
Keep it short and to the point. 0.77. What is the ratio of the Coal rent(as % of GDP) of Europe(developing only) in 2004 to that in 2012?
Your answer should be very brief. 1.03. What is the ratio of the Coal rent(as % of GDP) in Bosnia and Herzegovina in 2004 to that in 2012?
Your response must be concise. 0.28. What is the ratio of the Coal rent(as % of GDP) of East Asia (all income levels) in 2007 to that in 2008?
Offer a terse response. 0.34. What is the ratio of the Coal rent(as % of GDP) of Euro area in 2007 to that in 2008?
Give a very brief answer. 0.2. What is the ratio of the Coal rent(as % of GDP) of Europe(developing only) in 2007 to that in 2008?
Offer a terse response. 0.41. What is the ratio of the Coal rent(as % of GDP) of Bosnia and Herzegovina in 2007 to that in 2008?
Provide a short and direct response. 0.12. What is the ratio of the Coal rent(as % of GDP) in East Asia (all income levels) in 2007 to that in 2009?
Your response must be concise. 1.05. What is the ratio of the Coal rent(as % of GDP) in Euro area in 2007 to that in 2009?
Offer a terse response. 1.37. What is the ratio of the Coal rent(as % of GDP) in Bosnia and Herzegovina in 2007 to that in 2009?
Your answer should be very brief. 0.88. What is the ratio of the Coal rent(as % of GDP) in East Asia (all income levels) in 2007 to that in 2010?
Offer a very short reply. 0.59. What is the ratio of the Coal rent(as % of GDP) of Euro area in 2007 to that in 2010?
Offer a terse response. 0.48. What is the ratio of the Coal rent(as % of GDP) in Europe(developing only) in 2007 to that in 2010?
Offer a terse response. 0.65. What is the ratio of the Coal rent(as % of GDP) of Bosnia and Herzegovina in 2007 to that in 2010?
Make the answer very short. 0.26. What is the ratio of the Coal rent(as % of GDP) in East Asia (all income levels) in 2007 to that in 2011?
Give a very brief answer. 0.42. What is the ratio of the Coal rent(as % of GDP) in Euro area in 2007 to that in 2011?
Your answer should be very brief. 0.23. What is the ratio of the Coal rent(as % of GDP) of Europe(developing only) in 2007 to that in 2011?
Keep it short and to the point. 0.45. What is the ratio of the Coal rent(as % of GDP) of Bosnia and Herzegovina in 2007 to that in 2011?
Your answer should be very brief. 0.12. What is the ratio of the Coal rent(as % of GDP) in East Asia (all income levels) in 2007 to that in 2012?
Your answer should be very brief. 0.66. What is the ratio of the Coal rent(as % of GDP) in Euro area in 2007 to that in 2012?
Give a very brief answer. 0.66. What is the ratio of the Coal rent(as % of GDP) in Europe(developing only) in 2007 to that in 2012?
Your answer should be very brief. 0.68. What is the ratio of the Coal rent(as % of GDP) in Bosnia and Herzegovina in 2007 to that in 2012?
Your answer should be very brief. 0.26. What is the ratio of the Coal rent(as % of GDP) of East Asia (all income levels) in 2008 to that in 2009?
Your response must be concise. 3.11. What is the ratio of the Coal rent(as % of GDP) of Euro area in 2008 to that in 2009?
Make the answer very short. 6.99. What is the ratio of the Coal rent(as % of GDP) in Europe(developing only) in 2008 to that in 2009?
Provide a succinct answer. 2.43. What is the ratio of the Coal rent(as % of GDP) in Bosnia and Herzegovina in 2008 to that in 2009?
Your answer should be compact. 7.1. What is the ratio of the Coal rent(as % of GDP) of East Asia (all income levels) in 2008 to that in 2010?
Keep it short and to the point. 1.74. What is the ratio of the Coal rent(as % of GDP) in Euro area in 2008 to that in 2010?
Give a very brief answer. 2.45. What is the ratio of the Coal rent(as % of GDP) in Europe(developing only) in 2008 to that in 2010?
Offer a terse response. 1.61. What is the ratio of the Coal rent(as % of GDP) of Bosnia and Herzegovina in 2008 to that in 2010?
Offer a terse response. 2.13. What is the ratio of the Coal rent(as % of GDP) of East Asia (all income levels) in 2008 to that in 2011?
Provide a short and direct response. 1.23. What is the ratio of the Coal rent(as % of GDP) of Euro area in 2008 to that in 2011?
Your answer should be very brief. 1.19. What is the ratio of the Coal rent(as % of GDP) of Europe(developing only) in 2008 to that in 2011?
Your response must be concise. 1.12. What is the ratio of the Coal rent(as % of GDP) of Bosnia and Herzegovina in 2008 to that in 2011?
Give a very brief answer. 0.99. What is the ratio of the Coal rent(as % of GDP) in East Asia (all income levels) in 2008 to that in 2012?
Offer a very short reply. 1.95. What is the ratio of the Coal rent(as % of GDP) in Euro area in 2008 to that in 2012?
Ensure brevity in your answer.  3.4. What is the ratio of the Coal rent(as % of GDP) in Europe(developing only) in 2008 to that in 2012?
Provide a short and direct response. 1.67. What is the ratio of the Coal rent(as % of GDP) in Bosnia and Herzegovina in 2008 to that in 2012?
Your answer should be compact. 2.1. What is the ratio of the Coal rent(as % of GDP) in East Asia (all income levels) in 2009 to that in 2010?
Offer a very short reply. 0.56. What is the ratio of the Coal rent(as % of GDP) of Euro area in 2009 to that in 2010?
Your answer should be very brief. 0.35. What is the ratio of the Coal rent(as % of GDP) of Europe(developing only) in 2009 to that in 2010?
Ensure brevity in your answer.  0.66. What is the ratio of the Coal rent(as % of GDP) in Bosnia and Herzegovina in 2009 to that in 2010?
Keep it short and to the point. 0.3. What is the ratio of the Coal rent(as % of GDP) of East Asia (all income levels) in 2009 to that in 2011?
Your answer should be very brief. 0.4. What is the ratio of the Coal rent(as % of GDP) in Euro area in 2009 to that in 2011?
Give a very brief answer. 0.17. What is the ratio of the Coal rent(as % of GDP) in Europe(developing only) in 2009 to that in 2011?
Offer a very short reply. 0.46. What is the ratio of the Coal rent(as % of GDP) in Bosnia and Herzegovina in 2009 to that in 2011?
Offer a very short reply. 0.14. What is the ratio of the Coal rent(as % of GDP) in East Asia (all income levels) in 2009 to that in 2012?
Offer a terse response. 0.63. What is the ratio of the Coal rent(as % of GDP) of Euro area in 2009 to that in 2012?
Offer a very short reply. 0.49. What is the ratio of the Coal rent(as % of GDP) in Europe(developing only) in 2009 to that in 2012?
Make the answer very short. 0.69. What is the ratio of the Coal rent(as % of GDP) in Bosnia and Herzegovina in 2009 to that in 2012?
Ensure brevity in your answer.  0.3. What is the ratio of the Coal rent(as % of GDP) of East Asia (all income levels) in 2010 to that in 2011?
Make the answer very short. 0.71. What is the ratio of the Coal rent(as % of GDP) of Euro area in 2010 to that in 2011?
Your response must be concise. 0.49. What is the ratio of the Coal rent(as % of GDP) in Europe(developing only) in 2010 to that in 2011?
Your answer should be compact. 0.7. What is the ratio of the Coal rent(as % of GDP) in Bosnia and Herzegovina in 2010 to that in 2011?
Offer a terse response. 0.47. What is the ratio of the Coal rent(as % of GDP) in East Asia (all income levels) in 2010 to that in 2012?
Make the answer very short. 1.12. What is the ratio of the Coal rent(as % of GDP) in Euro area in 2010 to that in 2012?
Your response must be concise. 1.39. What is the ratio of the Coal rent(as % of GDP) in Europe(developing only) in 2010 to that in 2012?
Your response must be concise. 1.04. What is the ratio of the Coal rent(as % of GDP) in Bosnia and Herzegovina in 2010 to that in 2012?
Provide a short and direct response. 0.99. What is the ratio of the Coal rent(as % of GDP) of East Asia (all income levels) in 2011 to that in 2012?
Offer a very short reply. 1.58. What is the ratio of the Coal rent(as % of GDP) in Euro area in 2011 to that in 2012?
Your answer should be compact. 2.86. What is the ratio of the Coal rent(as % of GDP) in Europe(developing only) in 2011 to that in 2012?
Provide a short and direct response. 1.49. What is the ratio of the Coal rent(as % of GDP) of Bosnia and Herzegovina in 2011 to that in 2012?
Ensure brevity in your answer.  2.12. What is the difference between the highest and the second highest Coal rent(as % of GDP) of East Asia (all income levels)?
Give a very brief answer. 0.31. What is the difference between the highest and the second highest Coal rent(as % of GDP) in Euro area?
Provide a succinct answer. 0. What is the difference between the highest and the second highest Coal rent(as % of GDP) in Europe(developing only)?
Make the answer very short. 0.1. What is the difference between the highest and the second highest Coal rent(as % of GDP) of Bosnia and Herzegovina?
Give a very brief answer. 0.02. What is the difference between the highest and the lowest Coal rent(as % of GDP) of East Asia (all income levels)?
Give a very brief answer. 1.19. What is the difference between the highest and the lowest Coal rent(as % of GDP) in Euro area?
Make the answer very short. 0.02. What is the difference between the highest and the lowest Coal rent(as % of GDP) in Europe(developing only)?
Ensure brevity in your answer.  0.55. What is the difference between the highest and the lowest Coal rent(as % of GDP) of Bosnia and Herzegovina?
Provide a succinct answer. 2.1. 